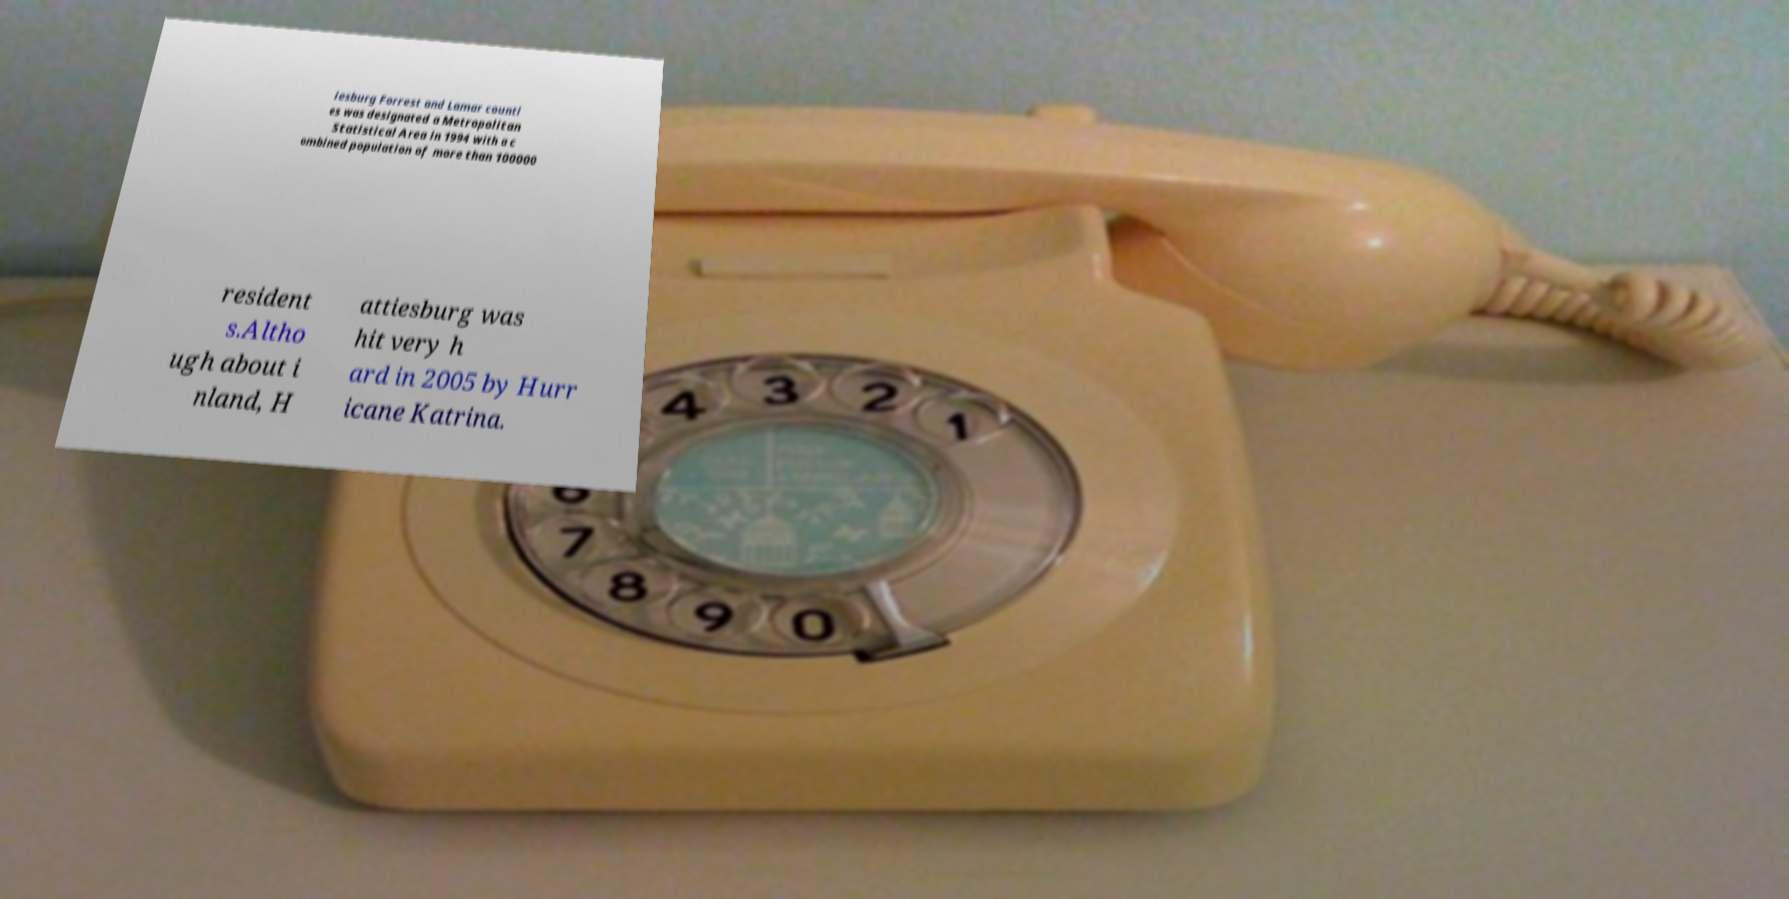Could you assist in decoding the text presented in this image and type it out clearly? iesburg Forrest and Lamar counti es was designated a Metropolitan Statistical Area in 1994 with a c ombined population of more than 100000 resident s.Altho ugh about i nland, H attiesburg was hit very h ard in 2005 by Hurr icane Katrina. 